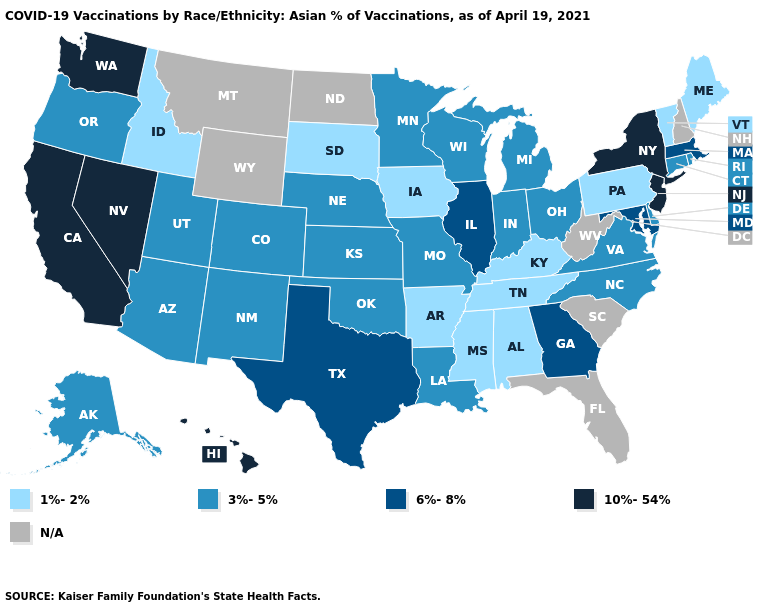Does Virginia have the highest value in the USA?
Concise answer only. No. Does New Jersey have the highest value in the Northeast?
Be succinct. Yes. What is the value of Delaware?
Write a very short answer. 3%-5%. Which states have the highest value in the USA?
Give a very brief answer. California, Hawaii, Nevada, New Jersey, New York, Washington. Name the states that have a value in the range 6%-8%?
Concise answer only. Georgia, Illinois, Maryland, Massachusetts, Texas. Name the states that have a value in the range 6%-8%?
Concise answer only. Georgia, Illinois, Maryland, Massachusetts, Texas. What is the value of New York?
Write a very short answer. 10%-54%. What is the value of Mississippi?
Be succinct. 1%-2%. Name the states that have a value in the range N/A?
Short answer required. Florida, Montana, New Hampshire, North Dakota, South Carolina, West Virginia, Wyoming. Name the states that have a value in the range 3%-5%?
Keep it brief. Alaska, Arizona, Colorado, Connecticut, Delaware, Indiana, Kansas, Louisiana, Michigan, Minnesota, Missouri, Nebraska, New Mexico, North Carolina, Ohio, Oklahoma, Oregon, Rhode Island, Utah, Virginia, Wisconsin. Among the states that border Nevada , which have the lowest value?
Be succinct. Idaho. What is the value of Ohio?
Quick response, please. 3%-5%. Which states have the highest value in the USA?
Concise answer only. California, Hawaii, Nevada, New Jersey, New York, Washington. Does Tennessee have the highest value in the USA?
Quick response, please. No. What is the value of Kentucky?
Write a very short answer. 1%-2%. 